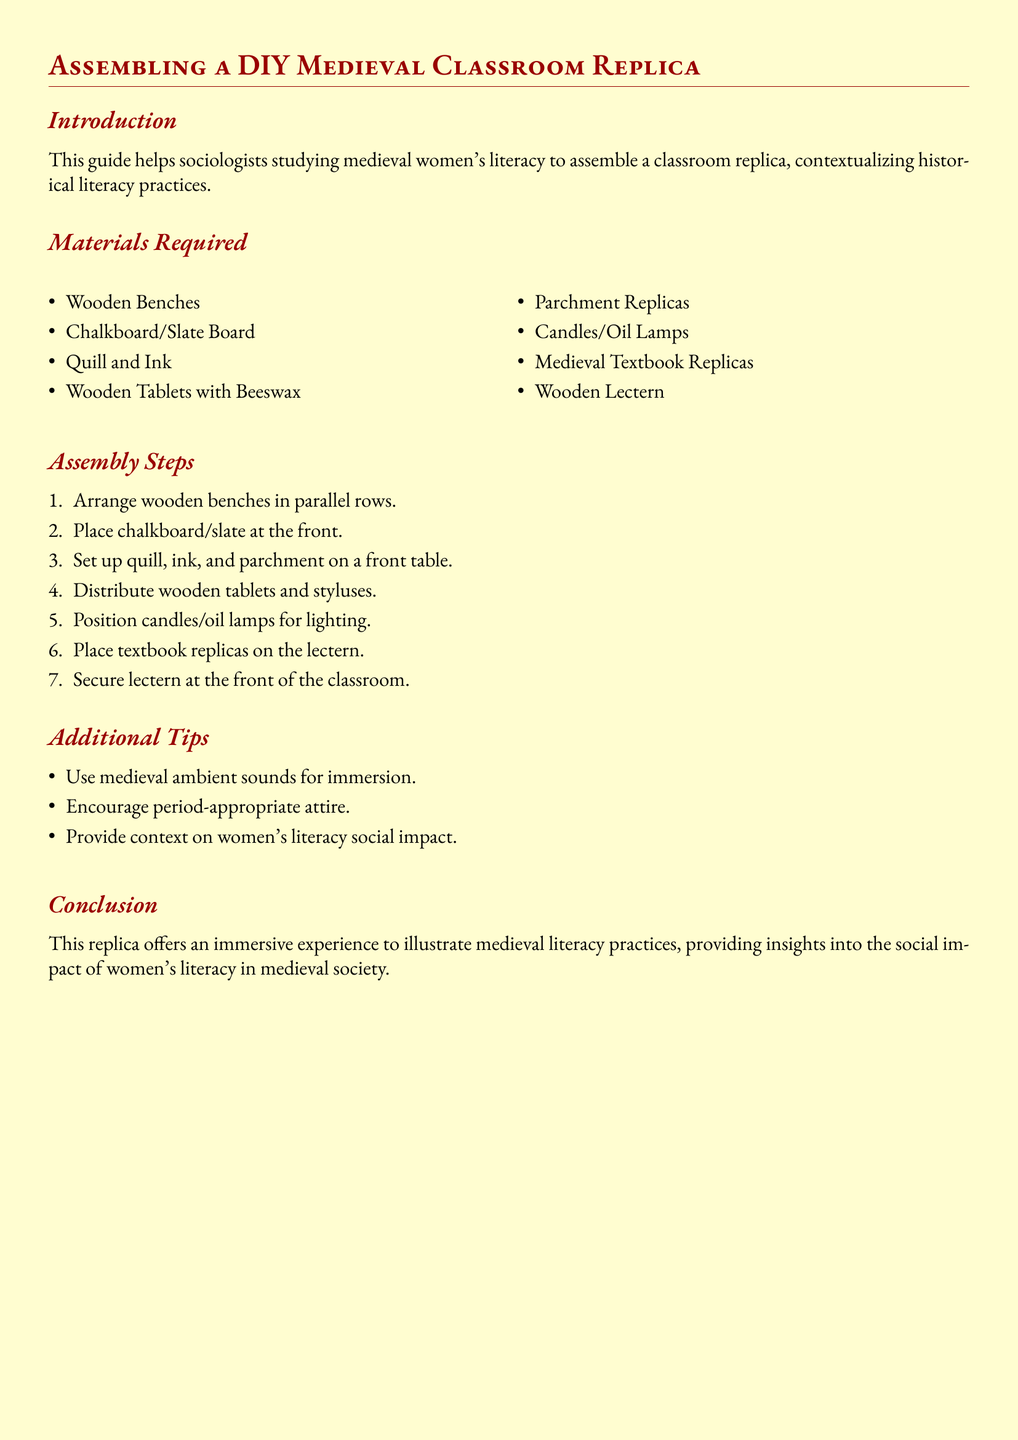What is the primary purpose of this guide? The primary purpose of the guide is to help sociologists studying medieval women's literacy to assemble a classroom replica.
Answer: To help sociologists How many items are listed under Materials Required? The number of items listed under Materials Required can be counted from the document, showing a total of eight items.
Answer: Eight Which item is used for lighting in the classroom? The document specifies the items required for lighting, and 'candles/oil lamps' is mentioned.
Answer: Candles/oil lamps What activity is suggested to enhance immersion? The guide mentions using ambient sounds as a method to create an immersive experience.
Answer: Medieval ambient sounds Where should the lectern be positioned? The document indicates that the lectern should be secured at the front of the classroom as part of the assembly steps.
Answer: At the front of the classroom What type of literacy does this classroom replica aim to illustrate? The document notes that the replica is intended to illustrate medieval literacy practices.
Answer: Medieval literacy practices What is included in the 'Additional Tips' section? The Additional Tips section contains suggestions that enhance the assembly experience, focusing on immersion and historical context.
Answer: Encourage period-appropriate attire How are the wooden benches arranged? The assembly steps clarify that wooden benches should be arranged in parallel rows.
Answer: In parallel rows What provides context on women's literacy social impact? The guide states that providing context on women's literacy social impact is one of the additional tips for enhancing the experience.
Answer: Context on women's literacy social impact 